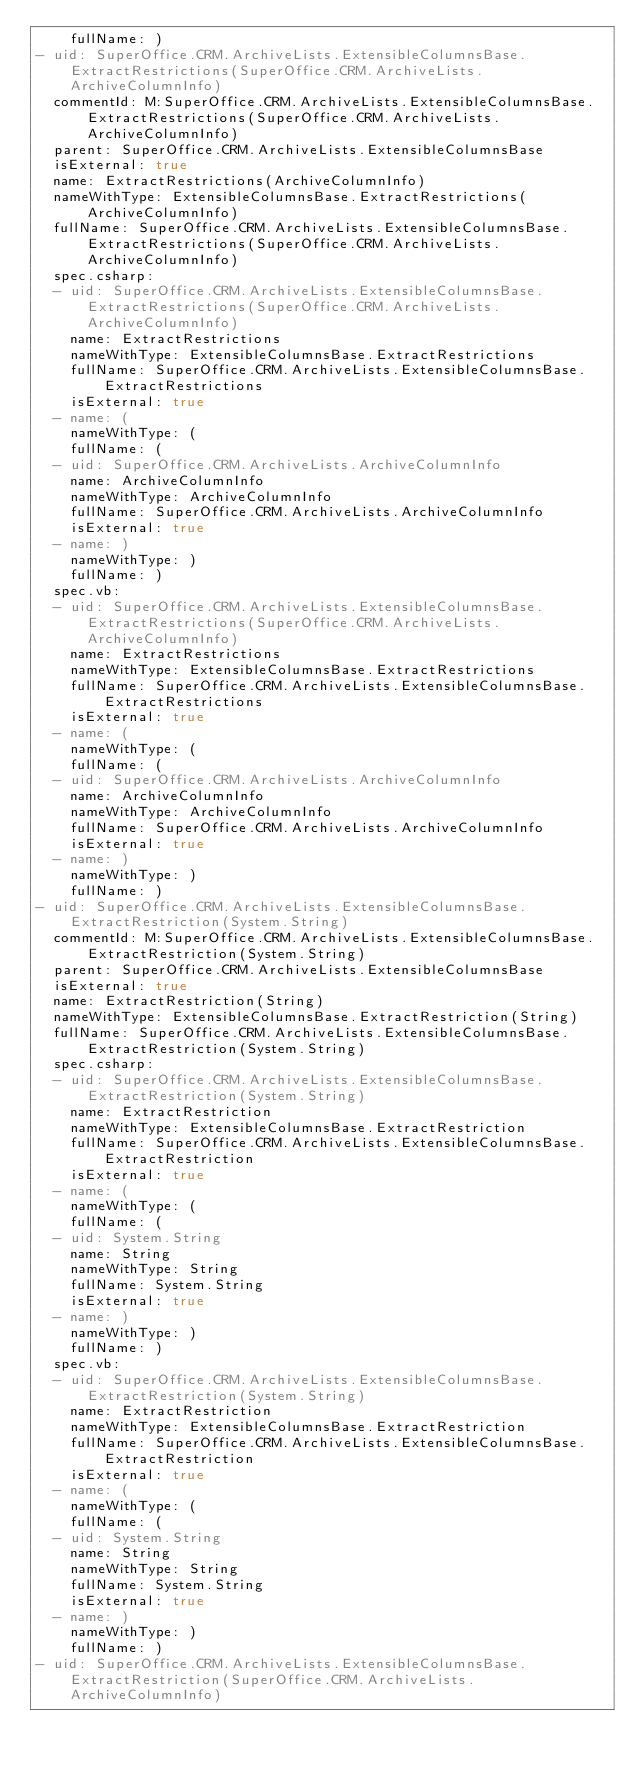Convert code to text. <code><loc_0><loc_0><loc_500><loc_500><_YAML_>    fullName: )
- uid: SuperOffice.CRM.ArchiveLists.ExtensibleColumnsBase.ExtractRestrictions(SuperOffice.CRM.ArchiveLists.ArchiveColumnInfo)
  commentId: M:SuperOffice.CRM.ArchiveLists.ExtensibleColumnsBase.ExtractRestrictions(SuperOffice.CRM.ArchiveLists.ArchiveColumnInfo)
  parent: SuperOffice.CRM.ArchiveLists.ExtensibleColumnsBase
  isExternal: true
  name: ExtractRestrictions(ArchiveColumnInfo)
  nameWithType: ExtensibleColumnsBase.ExtractRestrictions(ArchiveColumnInfo)
  fullName: SuperOffice.CRM.ArchiveLists.ExtensibleColumnsBase.ExtractRestrictions(SuperOffice.CRM.ArchiveLists.ArchiveColumnInfo)
  spec.csharp:
  - uid: SuperOffice.CRM.ArchiveLists.ExtensibleColumnsBase.ExtractRestrictions(SuperOffice.CRM.ArchiveLists.ArchiveColumnInfo)
    name: ExtractRestrictions
    nameWithType: ExtensibleColumnsBase.ExtractRestrictions
    fullName: SuperOffice.CRM.ArchiveLists.ExtensibleColumnsBase.ExtractRestrictions
    isExternal: true
  - name: (
    nameWithType: (
    fullName: (
  - uid: SuperOffice.CRM.ArchiveLists.ArchiveColumnInfo
    name: ArchiveColumnInfo
    nameWithType: ArchiveColumnInfo
    fullName: SuperOffice.CRM.ArchiveLists.ArchiveColumnInfo
    isExternal: true
  - name: )
    nameWithType: )
    fullName: )
  spec.vb:
  - uid: SuperOffice.CRM.ArchiveLists.ExtensibleColumnsBase.ExtractRestrictions(SuperOffice.CRM.ArchiveLists.ArchiveColumnInfo)
    name: ExtractRestrictions
    nameWithType: ExtensibleColumnsBase.ExtractRestrictions
    fullName: SuperOffice.CRM.ArchiveLists.ExtensibleColumnsBase.ExtractRestrictions
    isExternal: true
  - name: (
    nameWithType: (
    fullName: (
  - uid: SuperOffice.CRM.ArchiveLists.ArchiveColumnInfo
    name: ArchiveColumnInfo
    nameWithType: ArchiveColumnInfo
    fullName: SuperOffice.CRM.ArchiveLists.ArchiveColumnInfo
    isExternal: true
  - name: )
    nameWithType: )
    fullName: )
- uid: SuperOffice.CRM.ArchiveLists.ExtensibleColumnsBase.ExtractRestriction(System.String)
  commentId: M:SuperOffice.CRM.ArchiveLists.ExtensibleColumnsBase.ExtractRestriction(System.String)
  parent: SuperOffice.CRM.ArchiveLists.ExtensibleColumnsBase
  isExternal: true
  name: ExtractRestriction(String)
  nameWithType: ExtensibleColumnsBase.ExtractRestriction(String)
  fullName: SuperOffice.CRM.ArchiveLists.ExtensibleColumnsBase.ExtractRestriction(System.String)
  spec.csharp:
  - uid: SuperOffice.CRM.ArchiveLists.ExtensibleColumnsBase.ExtractRestriction(System.String)
    name: ExtractRestriction
    nameWithType: ExtensibleColumnsBase.ExtractRestriction
    fullName: SuperOffice.CRM.ArchiveLists.ExtensibleColumnsBase.ExtractRestriction
    isExternal: true
  - name: (
    nameWithType: (
    fullName: (
  - uid: System.String
    name: String
    nameWithType: String
    fullName: System.String
    isExternal: true
  - name: )
    nameWithType: )
    fullName: )
  spec.vb:
  - uid: SuperOffice.CRM.ArchiveLists.ExtensibleColumnsBase.ExtractRestriction(System.String)
    name: ExtractRestriction
    nameWithType: ExtensibleColumnsBase.ExtractRestriction
    fullName: SuperOffice.CRM.ArchiveLists.ExtensibleColumnsBase.ExtractRestriction
    isExternal: true
  - name: (
    nameWithType: (
    fullName: (
  - uid: System.String
    name: String
    nameWithType: String
    fullName: System.String
    isExternal: true
  - name: )
    nameWithType: )
    fullName: )
- uid: SuperOffice.CRM.ArchiveLists.ExtensibleColumnsBase.ExtractRestriction(SuperOffice.CRM.ArchiveLists.ArchiveColumnInfo)</code> 